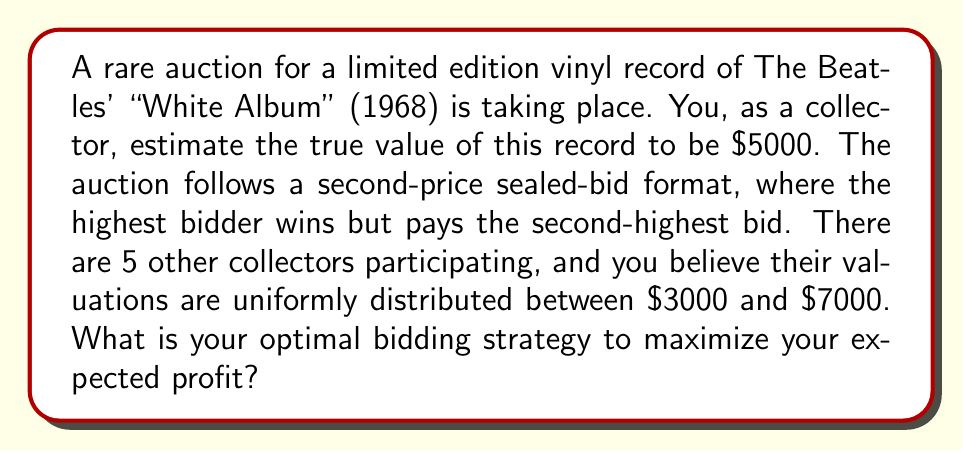Can you solve this math problem? To solve this problem, we need to understand the concept of dominant strategy in a second-price sealed-bid auction and apply it to our specific scenario.

1. In a second-price sealed-bid auction, the dominant strategy is to bid your true valuation. This is because:
   a. Bidding higher than your valuation risks paying more than the item is worth to you.
   b. Bidding lower than your valuation risks losing the auction for an item you value more than the winning price.

2. Your true valuation is $5000, so your optimal bid should be $5000.

3. To calculate your expected profit, we need to consider the probability of winning and the expected price you'll pay if you win.

4. The probability of winning is the probability that all other 5 bidders have a lower valuation than yours:

   $$P(\text{win}) = \left(\frac{5000 - 3000}{7000 - 3000}\right)^5 = \left(\frac{1}{2}\right)^5 = \frac{1}{32}$$

5. If you win, you'll pay the highest bid among the other bidders. The expected value of this is the expected value of the highest order statistic among 5 uniform random variables on [3000, 7000], given that they're all below 5000.

6. The expected value of the highest order statistic among n uniform random variables on [a, b] is:

   $$E = a + \frac{n}{n+1}(b-a)$$

   In our case, we need to adjust this for the condition that all bids are below 5000:

   $$E(\text{second highest bid} | \text{win}) = 3000 + \frac{5}{6}(5000-3000) = 4666.67$$

7. Your expected profit is:

   $$E(\text{profit}) = P(\text{win}) \times (5000 - E(\text{second highest bid} | \text{win}))$$
   $$E(\text{profit}) = \frac{1}{32} \times (5000 - 4666.67) = 10.42$$

This confirms that bidding your true valuation is indeed optimal, as it results in a positive expected profit.
Answer: The optimal bidding strategy is to bid your true valuation of $5000. This strategy yields an expected profit of $10.42. 